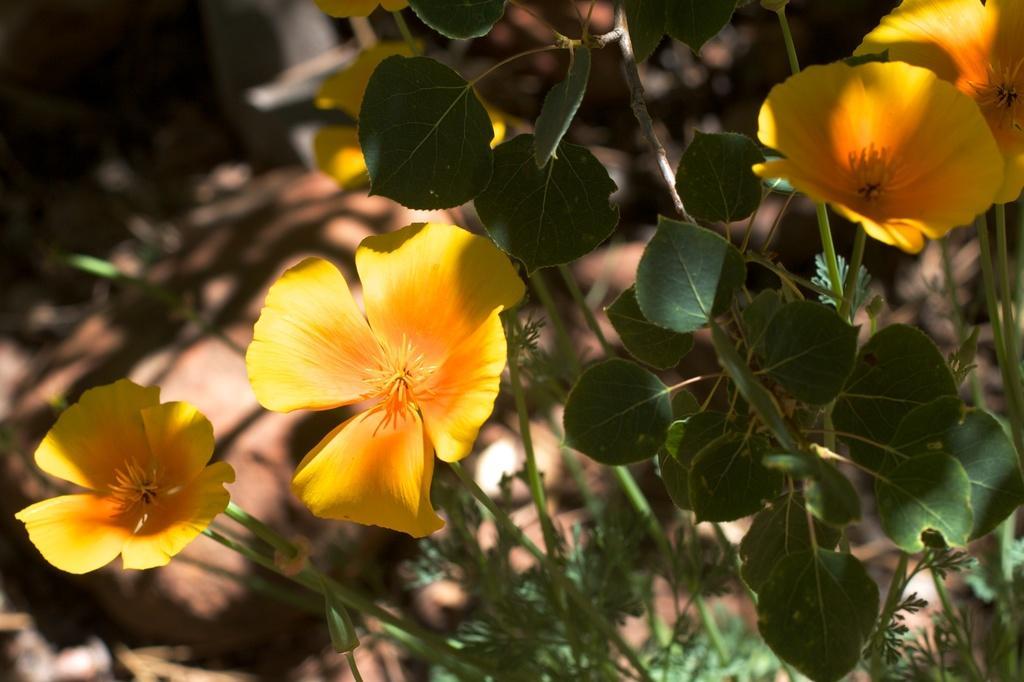Please provide a concise description of this image. In this image, we can see some yellow color flowers and there are some green color leaves. 